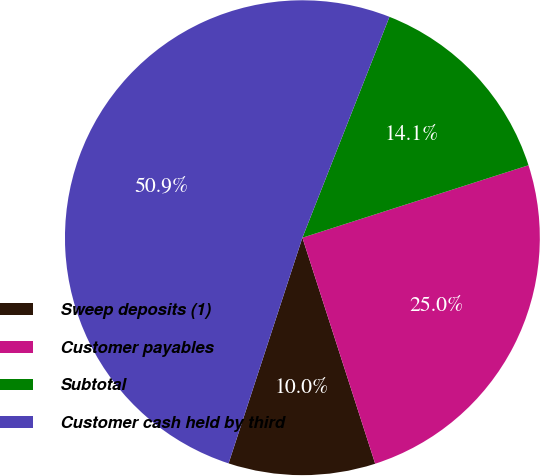Convert chart. <chart><loc_0><loc_0><loc_500><loc_500><pie_chart><fcel>Sweep deposits (1)<fcel>Customer payables<fcel>Subtotal<fcel>Customer cash held by third<nl><fcel>9.99%<fcel>24.98%<fcel>14.09%<fcel>50.95%<nl></chart> 